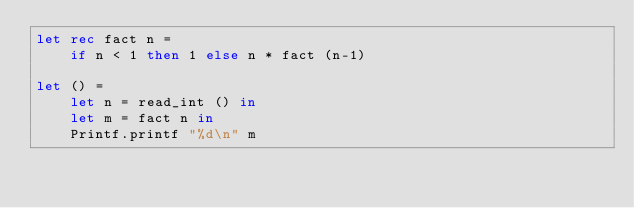<code> <loc_0><loc_0><loc_500><loc_500><_OCaml_>let rec fact n =
    if n < 1 then 1 else n * fact (n-1)

let () =
    let n = read_int () in
    let m = fact n in
    Printf.printf "%d\n" m</code> 